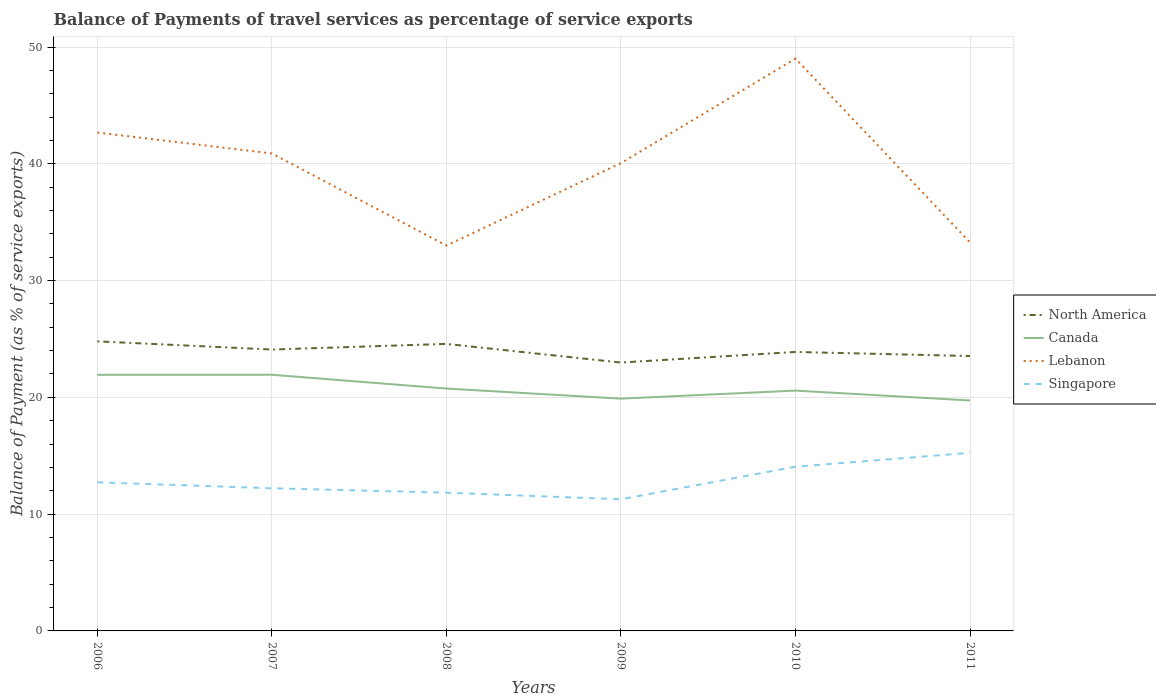Does the line corresponding to North America intersect with the line corresponding to Lebanon?
Your response must be concise. No. Across all years, what is the maximum balance of payments of travel services in Singapore?
Your answer should be very brief. 11.27. In which year was the balance of payments of travel services in Canada maximum?
Your response must be concise. 2011. What is the total balance of payments of travel services in Singapore in the graph?
Offer a very short reply. 0.51. What is the difference between the highest and the second highest balance of payments of travel services in Lebanon?
Make the answer very short. 16.01. Does the graph contain any zero values?
Your response must be concise. No. Does the graph contain grids?
Keep it short and to the point. Yes. How are the legend labels stacked?
Your response must be concise. Vertical. What is the title of the graph?
Offer a terse response. Balance of Payments of travel services as percentage of service exports. Does "Congo (Democratic)" appear as one of the legend labels in the graph?
Your answer should be very brief. No. What is the label or title of the X-axis?
Give a very brief answer. Years. What is the label or title of the Y-axis?
Your answer should be compact. Balance of Payment (as % of service exports). What is the Balance of Payment (as % of service exports) in North America in 2006?
Offer a terse response. 24.8. What is the Balance of Payment (as % of service exports) of Canada in 2006?
Provide a short and direct response. 21.93. What is the Balance of Payment (as % of service exports) of Lebanon in 2006?
Your answer should be very brief. 42.68. What is the Balance of Payment (as % of service exports) in Singapore in 2006?
Offer a terse response. 12.73. What is the Balance of Payment (as % of service exports) in North America in 2007?
Offer a terse response. 24.1. What is the Balance of Payment (as % of service exports) in Canada in 2007?
Provide a succinct answer. 21.94. What is the Balance of Payment (as % of service exports) in Lebanon in 2007?
Give a very brief answer. 40.89. What is the Balance of Payment (as % of service exports) of Singapore in 2007?
Ensure brevity in your answer.  12.22. What is the Balance of Payment (as % of service exports) of North America in 2008?
Give a very brief answer. 24.58. What is the Balance of Payment (as % of service exports) in Canada in 2008?
Your response must be concise. 20.75. What is the Balance of Payment (as % of service exports) in Lebanon in 2008?
Offer a very short reply. 33. What is the Balance of Payment (as % of service exports) of Singapore in 2008?
Offer a terse response. 11.84. What is the Balance of Payment (as % of service exports) in North America in 2009?
Provide a short and direct response. 22.98. What is the Balance of Payment (as % of service exports) in Canada in 2009?
Your answer should be very brief. 19.89. What is the Balance of Payment (as % of service exports) in Lebanon in 2009?
Keep it short and to the point. 40.06. What is the Balance of Payment (as % of service exports) of Singapore in 2009?
Your response must be concise. 11.27. What is the Balance of Payment (as % of service exports) of North America in 2010?
Provide a short and direct response. 23.89. What is the Balance of Payment (as % of service exports) in Canada in 2010?
Provide a short and direct response. 20.58. What is the Balance of Payment (as % of service exports) in Lebanon in 2010?
Offer a terse response. 49.01. What is the Balance of Payment (as % of service exports) of Singapore in 2010?
Your answer should be compact. 14.06. What is the Balance of Payment (as % of service exports) of North America in 2011?
Ensure brevity in your answer.  23.54. What is the Balance of Payment (as % of service exports) in Canada in 2011?
Your answer should be very brief. 19.73. What is the Balance of Payment (as % of service exports) of Lebanon in 2011?
Your response must be concise. 33.27. What is the Balance of Payment (as % of service exports) in Singapore in 2011?
Keep it short and to the point. 15.25. Across all years, what is the maximum Balance of Payment (as % of service exports) in North America?
Provide a succinct answer. 24.8. Across all years, what is the maximum Balance of Payment (as % of service exports) of Canada?
Your answer should be very brief. 21.94. Across all years, what is the maximum Balance of Payment (as % of service exports) in Lebanon?
Keep it short and to the point. 49.01. Across all years, what is the maximum Balance of Payment (as % of service exports) of Singapore?
Provide a succinct answer. 15.25. Across all years, what is the minimum Balance of Payment (as % of service exports) of North America?
Your response must be concise. 22.98. Across all years, what is the minimum Balance of Payment (as % of service exports) in Canada?
Offer a terse response. 19.73. Across all years, what is the minimum Balance of Payment (as % of service exports) of Lebanon?
Give a very brief answer. 33. Across all years, what is the minimum Balance of Payment (as % of service exports) in Singapore?
Offer a terse response. 11.27. What is the total Balance of Payment (as % of service exports) in North America in the graph?
Provide a short and direct response. 143.88. What is the total Balance of Payment (as % of service exports) of Canada in the graph?
Your answer should be very brief. 124.82. What is the total Balance of Payment (as % of service exports) in Lebanon in the graph?
Make the answer very short. 238.89. What is the total Balance of Payment (as % of service exports) in Singapore in the graph?
Provide a succinct answer. 77.36. What is the difference between the Balance of Payment (as % of service exports) in North America in 2006 and that in 2007?
Make the answer very short. 0.7. What is the difference between the Balance of Payment (as % of service exports) in Canada in 2006 and that in 2007?
Your answer should be compact. -0.01. What is the difference between the Balance of Payment (as % of service exports) in Lebanon in 2006 and that in 2007?
Offer a very short reply. 1.79. What is the difference between the Balance of Payment (as % of service exports) in Singapore in 2006 and that in 2007?
Your response must be concise. 0.51. What is the difference between the Balance of Payment (as % of service exports) in North America in 2006 and that in 2008?
Keep it short and to the point. 0.22. What is the difference between the Balance of Payment (as % of service exports) in Canada in 2006 and that in 2008?
Offer a very short reply. 1.18. What is the difference between the Balance of Payment (as % of service exports) in Lebanon in 2006 and that in 2008?
Offer a very short reply. 9.68. What is the difference between the Balance of Payment (as % of service exports) in North America in 2006 and that in 2009?
Provide a succinct answer. 1.82. What is the difference between the Balance of Payment (as % of service exports) in Canada in 2006 and that in 2009?
Keep it short and to the point. 2.04. What is the difference between the Balance of Payment (as % of service exports) in Lebanon in 2006 and that in 2009?
Your response must be concise. 2.62. What is the difference between the Balance of Payment (as % of service exports) of Singapore in 2006 and that in 2009?
Your answer should be very brief. 1.45. What is the difference between the Balance of Payment (as % of service exports) of North America in 2006 and that in 2010?
Keep it short and to the point. 0.91. What is the difference between the Balance of Payment (as % of service exports) of Canada in 2006 and that in 2010?
Make the answer very short. 1.35. What is the difference between the Balance of Payment (as % of service exports) in Lebanon in 2006 and that in 2010?
Your response must be concise. -6.33. What is the difference between the Balance of Payment (as % of service exports) of Singapore in 2006 and that in 2010?
Give a very brief answer. -1.33. What is the difference between the Balance of Payment (as % of service exports) in North America in 2006 and that in 2011?
Provide a short and direct response. 1.26. What is the difference between the Balance of Payment (as % of service exports) in Canada in 2006 and that in 2011?
Keep it short and to the point. 2.2. What is the difference between the Balance of Payment (as % of service exports) of Lebanon in 2006 and that in 2011?
Give a very brief answer. 9.41. What is the difference between the Balance of Payment (as % of service exports) of Singapore in 2006 and that in 2011?
Offer a very short reply. -2.53. What is the difference between the Balance of Payment (as % of service exports) of North America in 2007 and that in 2008?
Offer a very short reply. -0.48. What is the difference between the Balance of Payment (as % of service exports) of Canada in 2007 and that in 2008?
Keep it short and to the point. 1.18. What is the difference between the Balance of Payment (as % of service exports) in Lebanon in 2007 and that in 2008?
Offer a terse response. 7.89. What is the difference between the Balance of Payment (as % of service exports) of Singapore in 2007 and that in 2008?
Ensure brevity in your answer.  0.38. What is the difference between the Balance of Payment (as % of service exports) of North America in 2007 and that in 2009?
Offer a terse response. 1.11. What is the difference between the Balance of Payment (as % of service exports) of Canada in 2007 and that in 2009?
Your answer should be compact. 2.04. What is the difference between the Balance of Payment (as % of service exports) of Lebanon in 2007 and that in 2009?
Keep it short and to the point. 0.83. What is the difference between the Balance of Payment (as % of service exports) in Singapore in 2007 and that in 2009?
Your answer should be compact. 0.94. What is the difference between the Balance of Payment (as % of service exports) of North America in 2007 and that in 2010?
Make the answer very short. 0.21. What is the difference between the Balance of Payment (as % of service exports) in Canada in 2007 and that in 2010?
Offer a terse response. 1.36. What is the difference between the Balance of Payment (as % of service exports) in Lebanon in 2007 and that in 2010?
Offer a terse response. -8.12. What is the difference between the Balance of Payment (as % of service exports) in Singapore in 2007 and that in 2010?
Your answer should be compact. -1.84. What is the difference between the Balance of Payment (as % of service exports) of North America in 2007 and that in 2011?
Offer a terse response. 0.56. What is the difference between the Balance of Payment (as % of service exports) in Canada in 2007 and that in 2011?
Give a very brief answer. 2.2. What is the difference between the Balance of Payment (as % of service exports) of Lebanon in 2007 and that in 2011?
Keep it short and to the point. 7.62. What is the difference between the Balance of Payment (as % of service exports) in Singapore in 2007 and that in 2011?
Make the answer very short. -3.04. What is the difference between the Balance of Payment (as % of service exports) of North America in 2008 and that in 2009?
Ensure brevity in your answer.  1.6. What is the difference between the Balance of Payment (as % of service exports) in Canada in 2008 and that in 2009?
Keep it short and to the point. 0.86. What is the difference between the Balance of Payment (as % of service exports) in Lebanon in 2008 and that in 2009?
Make the answer very short. -7.06. What is the difference between the Balance of Payment (as % of service exports) in Singapore in 2008 and that in 2009?
Your answer should be compact. 0.56. What is the difference between the Balance of Payment (as % of service exports) of North America in 2008 and that in 2010?
Provide a succinct answer. 0.69. What is the difference between the Balance of Payment (as % of service exports) in Canada in 2008 and that in 2010?
Ensure brevity in your answer.  0.18. What is the difference between the Balance of Payment (as % of service exports) in Lebanon in 2008 and that in 2010?
Give a very brief answer. -16.01. What is the difference between the Balance of Payment (as % of service exports) in Singapore in 2008 and that in 2010?
Make the answer very short. -2.22. What is the difference between the Balance of Payment (as % of service exports) of North America in 2008 and that in 2011?
Offer a very short reply. 1.04. What is the difference between the Balance of Payment (as % of service exports) in Canada in 2008 and that in 2011?
Ensure brevity in your answer.  1.02. What is the difference between the Balance of Payment (as % of service exports) of Lebanon in 2008 and that in 2011?
Make the answer very short. -0.27. What is the difference between the Balance of Payment (as % of service exports) in Singapore in 2008 and that in 2011?
Your answer should be compact. -3.42. What is the difference between the Balance of Payment (as % of service exports) in North America in 2009 and that in 2010?
Your response must be concise. -0.91. What is the difference between the Balance of Payment (as % of service exports) of Canada in 2009 and that in 2010?
Provide a succinct answer. -0.69. What is the difference between the Balance of Payment (as % of service exports) in Lebanon in 2009 and that in 2010?
Your response must be concise. -8.95. What is the difference between the Balance of Payment (as % of service exports) in Singapore in 2009 and that in 2010?
Give a very brief answer. -2.79. What is the difference between the Balance of Payment (as % of service exports) of North America in 2009 and that in 2011?
Offer a terse response. -0.56. What is the difference between the Balance of Payment (as % of service exports) in Canada in 2009 and that in 2011?
Offer a very short reply. 0.16. What is the difference between the Balance of Payment (as % of service exports) in Lebanon in 2009 and that in 2011?
Make the answer very short. 6.79. What is the difference between the Balance of Payment (as % of service exports) in Singapore in 2009 and that in 2011?
Keep it short and to the point. -3.98. What is the difference between the Balance of Payment (as % of service exports) of North America in 2010 and that in 2011?
Make the answer very short. 0.35. What is the difference between the Balance of Payment (as % of service exports) in Canada in 2010 and that in 2011?
Keep it short and to the point. 0.84. What is the difference between the Balance of Payment (as % of service exports) in Lebanon in 2010 and that in 2011?
Your answer should be compact. 15.74. What is the difference between the Balance of Payment (as % of service exports) in Singapore in 2010 and that in 2011?
Provide a succinct answer. -1.19. What is the difference between the Balance of Payment (as % of service exports) in North America in 2006 and the Balance of Payment (as % of service exports) in Canada in 2007?
Your answer should be compact. 2.86. What is the difference between the Balance of Payment (as % of service exports) in North America in 2006 and the Balance of Payment (as % of service exports) in Lebanon in 2007?
Give a very brief answer. -16.09. What is the difference between the Balance of Payment (as % of service exports) in North America in 2006 and the Balance of Payment (as % of service exports) in Singapore in 2007?
Keep it short and to the point. 12.58. What is the difference between the Balance of Payment (as % of service exports) in Canada in 2006 and the Balance of Payment (as % of service exports) in Lebanon in 2007?
Your answer should be very brief. -18.96. What is the difference between the Balance of Payment (as % of service exports) in Canada in 2006 and the Balance of Payment (as % of service exports) in Singapore in 2007?
Provide a succinct answer. 9.71. What is the difference between the Balance of Payment (as % of service exports) in Lebanon in 2006 and the Balance of Payment (as % of service exports) in Singapore in 2007?
Provide a succinct answer. 30.46. What is the difference between the Balance of Payment (as % of service exports) in North America in 2006 and the Balance of Payment (as % of service exports) in Canada in 2008?
Give a very brief answer. 4.04. What is the difference between the Balance of Payment (as % of service exports) of North America in 2006 and the Balance of Payment (as % of service exports) of Lebanon in 2008?
Keep it short and to the point. -8.2. What is the difference between the Balance of Payment (as % of service exports) in North America in 2006 and the Balance of Payment (as % of service exports) in Singapore in 2008?
Provide a short and direct response. 12.96. What is the difference between the Balance of Payment (as % of service exports) of Canada in 2006 and the Balance of Payment (as % of service exports) of Lebanon in 2008?
Provide a succinct answer. -11.07. What is the difference between the Balance of Payment (as % of service exports) of Canada in 2006 and the Balance of Payment (as % of service exports) of Singapore in 2008?
Give a very brief answer. 10.09. What is the difference between the Balance of Payment (as % of service exports) of Lebanon in 2006 and the Balance of Payment (as % of service exports) of Singapore in 2008?
Your answer should be compact. 30.84. What is the difference between the Balance of Payment (as % of service exports) in North America in 2006 and the Balance of Payment (as % of service exports) in Canada in 2009?
Your answer should be very brief. 4.9. What is the difference between the Balance of Payment (as % of service exports) in North America in 2006 and the Balance of Payment (as % of service exports) in Lebanon in 2009?
Make the answer very short. -15.26. What is the difference between the Balance of Payment (as % of service exports) in North America in 2006 and the Balance of Payment (as % of service exports) in Singapore in 2009?
Offer a very short reply. 13.52. What is the difference between the Balance of Payment (as % of service exports) in Canada in 2006 and the Balance of Payment (as % of service exports) in Lebanon in 2009?
Ensure brevity in your answer.  -18.13. What is the difference between the Balance of Payment (as % of service exports) in Canada in 2006 and the Balance of Payment (as % of service exports) in Singapore in 2009?
Provide a succinct answer. 10.66. What is the difference between the Balance of Payment (as % of service exports) in Lebanon in 2006 and the Balance of Payment (as % of service exports) in Singapore in 2009?
Offer a terse response. 31.4. What is the difference between the Balance of Payment (as % of service exports) of North America in 2006 and the Balance of Payment (as % of service exports) of Canada in 2010?
Offer a very short reply. 4.22. What is the difference between the Balance of Payment (as % of service exports) of North America in 2006 and the Balance of Payment (as % of service exports) of Lebanon in 2010?
Ensure brevity in your answer.  -24.21. What is the difference between the Balance of Payment (as % of service exports) of North America in 2006 and the Balance of Payment (as % of service exports) of Singapore in 2010?
Provide a short and direct response. 10.74. What is the difference between the Balance of Payment (as % of service exports) of Canada in 2006 and the Balance of Payment (as % of service exports) of Lebanon in 2010?
Your response must be concise. -27.08. What is the difference between the Balance of Payment (as % of service exports) in Canada in 2006 and the Balance of Payment (as % of service exports) in Singapore in 2010?
Your answer should be compact. 7.87. What is the difference between the Balance of Payment (as % of service exports) of Lebanon in 2006 and the Balance of Payment (as % of service exports) of Singapore in 2010?
Give a very brief answer. 28.61. What is the difference between the Balance of Payment (as % of service exports) of North America in 2006 and the Balance of Payment (as % of service exports) of Canada in 2011?
Make the answer very short. 5.06. What is the difference between the Balance of Payment (as % of service exports) in North America in 2006 and the Balance of Payment (as % of service exports) in Lebanon in 2011?
Offer a very short reply. -8.47. What is the difference between the Balance of Payment (as % of service exports) in North America in 2006 and the Balance of Payment (as % of service exports) in Singapore in 2011?
Give a very brief answer. 9.54. What is the difference between the Balance of Payment (as % of service exports) of Canada in 2006 and the Balance of Payment (as % of service exports) of Lebanon in 2011?
Your answer should be very brief. -11.34. What is the difference between the Balance of Payment (as % of service exports) of Canada in 2006 and the Balance of Payment (as % of service exports) of Singapore in 2011?
Provide a succinct answer. 6.68. What is the difference between the Balance of Payment (as % of service exports) in Lebanon in 2006 and the Balance of Payment (as % of service exports) in Singapore in 2011?
Your response must be concise. 27.42. What is the difference between the Balance of Payment (as % of service exports) of North America in 2007 and the Balance of Payment (as % of service exports) of Canada in 2008?
Provide a succinct answer. 3.34. What is the difference between the Balance of Payment (as % of service exports) of North America in 2007 and the Balance of Payment (as % of service exports) of Lebanon in 2008?
Offer a very short reply. -8.9. What is the difference between the Balance of Payment (as % of service exports) of North America in 2007 and the Balance of Payment (as % of service exports) of Singapore in 2008?
Your response must be concise. 12.26. What is the difference between the Balance of Payment (as % of service exports) in Canada in 2007 and the Balance of Payment (as % of service exports) in Lebanon in 2008?
Make the answer very short. -11.06. What is the difference between the Balance of Payment (as % of service exports) in Canada in 2007 and the Balance of Payment (as % of service exports) in Singapore in 2008?
Offer a terse response. 10.1. What is the difference between the Balance of Payment (as % of service exports) of Lebanon in 2007 and the Balance of Payment (as % of service exports) of Singapore in 2008?
Provide a succinct answer. 29.05. What is the difference between the Balance of Payment (as % of service exports) of North America in 2007 and the Balance of Payment (as % of service exports) of Canada in 2009?
Provide a succinct answer. 4.2. What is the difference between the Balance of Payment (as % of service exports) in North America in 2007 and the Balance of Payment (as % of service exports) in Lebanon in 2009?
Provide a short and direct response. -15.96. What is the difference between the Balance of Payment (as % of service exports) of North America in 2007 and the Balance of Payment (as % of service exports) of Singapore in 2009?
Keep it short and to the point. 12.82. What is the difference between the Balance of Payment (as % of service exports) in Canada in 2007 and the Balance of Payment (as % of service exports) in Lebanon in 2009?
Ensure brevity in your answer.  -18.12. What is the difference between the Balance of Payment (as % of service exports) of Canada in 2007 and the Balance of Payment (as % of service exports) of Singapore in 2009?
Your answer should be compact. 10.66. What is the difference between the Balance of Payment (as % of service exports) in Lebanon in 2007 and the Balance of Payment (as % of service exports) in Singapore in 2009?
Keep it short and to the point. 29.61. What is the difference between the Balance of Payment (as % of service exports) in North America in 2007 and the Balance of Payment (as % of service exports) in Canada in 2010?
Offer a very short reply. 3.52. What is the difference between the Balance of Payment (as % of service exports) in North America in 2007 and the Balance of Payment (as % of service exports) in Lebanon in 2010?
Provide a short and direct response. -24.91. What is the difference between the Balance of Payment (as % of service exports) in North America in 2007 and the Balance of Payment (as % of service exports) in Singapore in 2010?
Provide a succinct answer. 10.04. What is the difference between the Balance of Payment (as % of service exports) of Canada in 2007 and the Balance of Payment (as % of service exports) of Lebanon in 2010?
Provide a succinct answer. -27.07. What is the difference between the Balance of Payment (as % of service exports) in Canada in 2007 and the Balance of Payment (as % of service exports) in Singapore in 2010?
Provide a short and direct response. 7.87. What is the difference between the Balance of Payment (as % of service exports) of Lebanon in 2007 and the Balance of Payment (as % of service exports) of Singapore in 2010?
Provide a short and direct response. 26.82. What is the difference between the Balance of Payment (as % of service exports) in North America in 2007 and the Balance of Payment (as % of service exports) in Canada in 2011?
Keep it short and to the point. 4.36. What is the difference between the Balance of Payment (as % of service exports) in North America in 2007 and the Balance of Payment (as % of service exports) in Lebanon in 2011?
Offer a terse response. -9.17. What is the difference between the Balance of Payment (as % of service exports) in North America in 2007 and the Balance of Payment (as % of service exports) in Singapore in 2011?
Provide a short and direct response. 8.84. What is the difference between the Balance of Payment (as % of service exports) in Canada in 2007 and the Balance of Payment (as % of service exports) in Lebanon in 2011?
Provide a succinct answer. -11.33. What is the difference between the Balance of Payment (as % of service exports) of Canada in 2007 and the Balance of Payment (as % of service exports) of Singapore in 2011?
Your answer should be very brief. 6.68. What is the difference between the Balance of Payment (as % of service exports) of Lebanon in 2007 and the Balance of Payment (as % of service exports) of Singapore in 2011?
Offer a very short reply. 25.63. What is the difference between the Balance of Payment (as % of service exports) in North America in 2008 and the Balance of Payment (as % of service exports) in Canada in 2009?
Your answer should be very brief. 4.68. What is the difference between the Balance of Payment (as % of service exports) of North America in 2008 and the Balance of Payment (as % of service exports) of Lebanon in 2009?
Make the answer very short. -15.48. What is the difference between the Balance of Payment (as % of service exports) of North America in 2008 and the Balance of Payment (as % of service exports) of Singapore in 2009?
Your response must be concise. 13.3. What is the difference between the Balance of Payment (as % of service exports) in Canada in 2008 and the Balance of Payment (as % of service exports) in Lebanon in 2009?
Your response must be concise. -19.31. What is the difference between the Balance of Payment (as % of service exports) of Canada in 2008 and the Balance of Payment (as % of service exports) of Singapore in 2009?
Make the answer very short. 9.48. What is the difference between the Balance of Payment (as % of service exports) of Lebanon in 2008 and the Balance of Payment (as % of service exports) of Singapore in 2009?
Make the answer very short. 21.72. What is the difference between the Balance of Payment (as % of service exports) in North America in 2008 and the Balance of Payment (as % of service exports) in Canada in 2010?
Provide a succinct answer. 4. What is the difference between the Balance of Payment (as % of service exports) in North America in 2008 and the Balance of Payment (as % of service exports) in Lebanon in 2010?
Make the answer very short. -24.43. What is the difference between the Balance of Payment (as % of service exports) in North America in 2008 and the Balance of Payment (as % of service exports) in Singapore in 2010?
Give a very brief answer. 10.52. What is the difference between the Balance of Payment (as % of service exports) in Canada in 2008 and the Balance of Payment (as % of service exports) in Lebanon in 2010?
Give a very brief answer. -28.25. What is the difference between the Balance of Payment (as % of service exports) in Canada in 2008 and the Balance of Payment (as % of service exports) in Singapore in 2010?
Provide a succinct answer. 6.69. What is the difference between the Balance of Payment (as % of service exports) of Lebanon in 2008 and the Balance of Payment (as % of service exports) of Singapore in 2010?
Provide a succinct answer. 18.94. What is the difference between the Balance of Payment (as % of service exports) of North America in 2008 and the Balance of Payment (as % of service exports) of Canada in 2011?
Offer a very short reply. 4.84. What is the difference between the Balance of Payment (as % of service exports) in North America in 2008 and the Balance of Payment (as % of service exports) in Lebanon in 2011?
Ensure brevity in your answer.  -8.69. What is the difference between the Balance of Payment (as % of service exports) in North America in 2008 and the Balance of Payment (as % of service exports) in Singapore in 2011?
Your answer should be compact. 9.32. What is the difference between the Balance of Payment (as % of service exports) of Canada in 2008 and the Balance of Payment (as % of service exports) of Lebanon in 2011?
Provide a succinct answer. -12.51. What is the difference between the Balance of Payment (as % of service exports) in Canada in 2008 and the Balance of Payment (as % of service exports) in Singapore in 2011?
Your answer should be very brief. 5.5. What is the difference between the Balance of Payment (as % of service exports) in Lebanon in 2008 and the Balance of Payment (as % of service exports) in Singapore in 2011?
Your answer should be compact. 17.74. What is the difference between the Balance of Payment (as % of service exports) in North America in 2009 and the Balance of Payment (as % of service exports) in Canada in 2010?
Provide a short and direct response. 2.4. What is the difference between the Balance of Payment (as % of service exports) in North America in 2009 and the Balance of Payment (as % of service exports) in Lebanon in 2010?
Your answer should be very brief. -26.03. What is the difference between the Balance of Payment (as % of service exports) in North America in 2009 and the Balance of Payment (as % of service exports) in Singapore in 2010?
Your answer should be compact. 8.92. What is the difference between the Balance of Payment (as % of service exports) of Canada in 2009 and the Balance of Payment (as % of service exports) of Lebanon in 2010?
Keep it short and to the point. -29.11. What is the difference between the Balance of Payment (as % of service exports) of Canada in 2009 and the Balance of Payment (as % of service exports) of Singapore in 2010?
Provide a short and direct response. 5.83. What is the difference between the Balance of Payment (as % of service exports) of Lebanon in 2009 and the Balance of Payment (as % of service exports) of Singapore in 2010?
Make the answer very short. 26. What is the difference between the Balance of Payment (as % of service exports) in North America in 2009 and the Balance of Payment (as % of service exports) in Canada in 2011?
Provide a succinct answer. 3.25. What is the difference between the Balance of Payment (as % of service exports) in North America in 2009 and the Balance of Payment (as % of service exports) in Lebanon in 2011?
Your answer should be compact. -10.29. What is the difference between the Balance of Payment (as % of service exports) in North America in 2009 and the Balance of Payment (as % of service exports) in Singapore in 2011?
Your answer should be compact. 7.73. What is the difference between the Balance of Payment (as % of service exports) of Canada in 2009 and the Balance of Payment (as % of service exports) of Lebanon in 2011?
Make the answer very short. -13.38. What is the difference between the Balance of Payment (as % of service exports) in Canada in 2009 and the Balance of Payment (as % of service exports) in Singapore in 2011?
Your response must be concise. 4.64. What is the difference between the Balance of Payment (as % of service exports) of Lebanon in 2009 and the Balance of Payment (as % of service exports) of Singapore in 2011?
Your answer should be very brief. 24.81. What is the difference between the Balance of Payment (as % of service exports) in North America in 2010 and the Balance of Payment (as % of service exports) in Canada in 2011?
Offer a terse response. 4.16. What is the difference between the Balance of Payment (as % of service exports) of North America in 2010 and the Balance of Payment (as % of service exports) of Lebanon in 2011?
Make the answer very short. -9.38. What is the difference between the Balance of Payment (as % of service exports) in North America in 2010 and the Balance of Payment (as % of service exports) in Singapore in 2011?
Offer a terse response. 8.64. What is the difference between the Balance of Payment (as % of service exports) of Canada in 2010 and the Balance of Payment (as % of service exports) of Lebanon in 2011?
Your response must be concise. -12.69. What is the difference between the Balance of Payment (as % of service exports) of Canada in 2010 and the Balance of Payment (as % of service exports) of Singapore in 2011?
Keep it short and to the point. 5.33. What is the difference between the Balance of Payment (as % of service exports) in Lebanon in 2010 and the Balance of Payment (as % of service exports) in Singapore in 2011?
Make the answer very short. 33.75. What is the average Balance of Payment (as % of service exports) in North America per year?
Keep it short and to the point. 23.98. What is the average Balance of Payment (as % of service exports) of Canada per year?
Your response must be concise. 20.8. What is the average Balance of Payment (as % of service exports) of Lebanon per year?
Offer a very short reply. 39.82. What is the average Balance of Payment (as % of service exports) in Singapore per year?
Ensure brevity in your answer.  12.89. In the year 2006, what is the difference between the Balance of Payment (as % of service exports) of North America and Balance of Payment (as % of service exports) of Canada?
Make the answer very short. 2.87. In the year 2006, what is the difference between the Balance of Payment (as % of service exports) of North America and Balance of Payment (as % of service exports) of Lebanon?
Your response must be concise. -17.88. In the year 2006, what is the difference between the Balance of Payment (as % of service exports) in North America and Balance of Payment (as % of service exports) in Singapore?
Your answer should be very brief. 12.07. In the year 2006, what is the difference between the Balance of Payment (as % of service exports) in Canada and Balance of Payment (as % of service exports) in Lebanon?
Provide a succinct answer. -20.75. In the year 2006, what is the difference between the Balance of Payment (as % of service exports) of Canada and Balance of Payment (as % of service exports) of Singapore?
Keep it short and to the point. 9.2. In the year 2006, what is the difference between the Balance of Payment (as % of service exports) of Lebanon and Balance of Payment (as % of service exports) of Singapore?
Your answer should be compact. 29.95. In the year 2007, what is the difference between the Balance of Payment (as % of service exports) in North America and Balance of Payment (as % of service exports) in Canada?
Your answer should be very brief. 2.16. In the year 2007, what is the difference between the Balance of Payment (as % of service exports) of North America and Balance of Payment (as % of service exports) of Lebanon?
Your answer should be very brief. -16.79. In the year 2007, what is the difference between the Balance of Payment (as % of service exports) of North America and Balance of Payment (as % of service exports) of Singapore?
Offer a very short reply. 11.88. In the year 2007, what is the difference between the Balance of Payment (as % of service exports) of Canada and Balance of Payment (as % of service exports) of Lebanon?
Your response must be concise. -18.95. In the year 2007, what is the difference between the Balance of Payment (as % of service exports) in Canada and Balance of Payment (as % of service exports) in Singapore?
Keep it short and to the point. 9.72. In the year 2007, what is the difference between the Balance of Payment (as % of service exports) of Lebanon and Balance of Payment (as % of service exports) of Singapore?
Keep it short and to the point. 28.67. In the year 2008, what is the difference between the Balance of Payment (as % of service exports) in North America and Balance of Payment (as % of service exports) in Canada?
Ensure brevity in your answer.  3.82. In the year 2008, what is the difference between the Balance of Payment (as % of service exports) in North America and Balance of Payment (as % of service exports) in Lebanon?
Ensure brevity in your answer.  -8.42. In the year 2008, what is the difference between the Balance of Payment (as % of service exports) in North America and Balance of Payment (as % of service exports) in Singapore?
Give a very brief answer. 12.74. In the year 2008, what is the difference between the Balance of Payment (as % of service exports) in Canada and Balance of Payment (as % of service exports) in Lebanon?
Ensure brevity in your answer.  -12.24. In the year 2008, what is the difference between the Balance of Payment (as % of service exports) in Canada and Balance of Payment (as % of service exports) in Singapore?
Your answer should be very brief. 8.92. In the year 2008, what is the difference between the Balance of Payment (as % of service exports) in Lebanon and Balance of Payment (as % of service exports) in Singapore?
Provide a short and direct response. 21.16. In the year 2009, what is the difference between the Balance of Payment (as % of service exports) in North America and Balance of Payment (as % of service exports) in Canada?
Offer a very short reply. 3.09. In the year 2009, what is the difference between the Balance of Payment (as % of service exports) of North America and Balance of Payment (as % of service exports) of Lebanon?
Provide a short and direct response. -17.08. In the year 2009, what is the difference between the Balance of Payment (as % of service exports) in North America and Balance of Payment (as % of service exports) in Singapore?
Your response must be concise. 11.71. In the year 2009, what is the difference between the Balance of Payment (as % of service exports) of Canada and Balance of Payment (as % of service exports) of Lebanon?
Make the answer very short. -20.17. In the year 2009, what is the difference between the Balance of Payment (as % of service exports) in Canada and Balance of Payment (as % of service exports) in Singapore?
Keep it short and to the point. 8.62. In the year 2009, what is the difference between the Balance of Payment (as % of service exports) in Lebanon and Balance of Payment (as % of service exports) in Singapore?
Your response must be concise. 28.79. In the year 2010, what is the difference between the Balance of Payment (as % of service exports) of North America and Balance of Payment (as % of service exports) of Canada?
Provide a succinct answer. 3.31. In the year 2010, what is the difference between the Balance of Payment (as % of service exports) in North America and Balance of Payment (as % of service exports) in Lebanon?
Provide a succinct answer. -25.12. In the year 2010, what is the difference between the Balance of Payment (as % of service exports) in North America and Balance of Payment (as % of service exports) in Singapore?
Keep it short and to the point. 9.83. In the year 2010, what is the difference between the Balance of Payment (as % of service exports) in Canada and Balance of Payment (as % of service exports) in Lebanon?
Keep it short and to the point. -28.43. In the year 2010, what is the difference between the Balance of Payment (as % of service exports) of Canada and Balance of Payment (as % of service exports) of Singapore?
Keep it short and to the point. 6.52. In the year 2010, what is the difference between the Balance of Payment (as % of service exports) of Lebanon and Balance of Payment (as % of service exports) of Singapore?
Provide a succinct answer. 34.95. In the year 2011, what is the difference between the Balance of Payment (as % of service exports) of North America and Balance of Payment (as % of service exports) of Canada?
Provide a succinct answer. 3.81. In the year 2011, what is the difference between the Balance of Payment (as % of service exports) of North America and Balance of Payment (as % of service exports) of Lebanon?
Give a very brief answer. -9.73. In the year 2011, what is the difference between the Balance of Payment (as % of service exports) in North America and Balance of Payment (as % of service exports) in Singapore?
Give a very brief answer. 8.29. In the year 2011, what is the difference between the Balance of Payment (as % of service exports) of Canada and Balance of Payment (as % of service exports) of Lebanon?
Provide a succinct answer. -13.54. In the year 2011, what is the difference between the Balance of Payment (as % of service exports) of Canada and Balance of Payment (as % of service exports) of Singapore?
Your answer should be compact. 4.48. In the year 2011, what is the difference between the Balance of Payment (as % of service exports) in Lebanon and Balance of Payment (as % of service exports) in Singapore?
Offer a very short reply. 18.02. What is the ratio of the Balance of Payment (as % of service exports) in North America in 2006 to that in 2007?
Offer a terse response. 1.03. What is the ratio of the Balance of Payment (as % of service exports) in Lebanon in 2006 to that in 2007?
Provide a succinct answer. 1.04. What is the ratio of the Balance of Payment (as % of service exports) in Singapore in 2006 to that in 2007?
Offer a terse response. 1.04. What is the ratio of the Balance of Payment (as % of service exports) of North America in 2006 to that in 2008?
Make the answer very short. 1.01. What is the ratio of the Balance of Payment (as % of service exports) in Canada in 2006 to that in 2008?
Offer a terse response. 1.06. What is the ratio of the Balance of Payment (as % of service exports) in Lebanon in 2006 to that in 2008?
Your answer should be very brief. 1.29. What is the ratio of the Balance of Payment (as % of service exports) in Singapore in 2006 to that in 2008?
Offer a terse response. 1.08. What is the ratio of the Balance of Payment (as % of service exports) of North America in 2006 to that in 2009?
Your response must be concise. 1.08. What is the ratio of the Balance of Payment (as % of service exports) of Canada in 2006 to that in 2009?
Your answer should be very brief. 1.1. What is the ratio of the Balance of Payment (as % of service exports) of Lebanon in 2006 to that in 2009?
Provide a short and direct response. 1.07. What is the ratio of the Balance of Payment (as % of service exports) in Singapore in 2006 to that in 2009?
Provide a succinct answer. 1.13. What is the ratio of the Balance of Payment (as % of service exports) in North America in 2006 to that in 2010?
Your response must be concise. 1.04. What is the ratio of the Balance of Payment (as % of service exports) of Canada in 2006 to that in 2010?
Your response must be concise. 1.07. What is the ratio of the Balance of Payment (as % of service exports) of Lebanon in 2006 to that in 2010?
Your answer should be very brief. 0.87. What is the ratio of the Balance of Payment (as % of service exports) of Singapore in 2006 to that in 2010?
Offer a very short reply. 0.91. What is the ratio of the Balance of Payment (as % of service exports) in North America in 2006 to that in 2011?
Make the answer very short. 1.05. What is the ratio of the Balance of Payment (as % of service exports) in Canada in 2006 to that in 2011?
Give a very brief answer. 1.11. What is the ratio of the Balance of Payment (as % of service exports) in Lebanon in 2006 to that in 2011?
Provide a short and direct response. 1.28. What is the ratio of the Balance of Payment (as % of service exports) in Singapore in 2006 to that in 2011?
Give a very brief answer. 0.83. What is the ratio of the Balance of Payment (as % of service exports) of North America in 2007 to that in 2008?
Offer a terse response. 0.98. What is the ratio of the Balance of Payment (as % of service exports) in Canada in 2007 to that in 2008?
Offer a terse response. 1.06. What is the ratio of the Balance of Payment (as % of service exports) of Lebanon in 2007 to that in 2008?
Provide a succinct answer. 1.24. What is the ratio of the Balance of Payment (as % of service exports) of Singapore in 2007 to that in 2008?
Your answer should be very brief. 1.03. What is the ratio of the Balance of Payment (as % of service exports) of North America in 2007 to that in 2009?
Offer a terse response. 1.05. What is the ratio of the Balance of Payment (as % of service exports) in Canada in 2007 to that in 2009?
Ensure brevity in your answer.  1.1. What is the ratio of the Balance of Payment (as % of service exports) of Lebanon in 2007 to that in 2009?
Your answer should be compact. 1.02. What is the ratio of the Balance of Payment (as % of service exports) of Singapore in 2007 to that in 2009?
Your answer should be very brief. 1.08. What is the ratio of the Balance of Payment (as % of service exports) of North America in 2007 to that in 2010?
Give a very brief answer. 1.01. What is the ratio of the Balance of Payment (as % of service exports) of Canada in 2007 to that in 2010?
Give a very brief answer. 1.07. What is the ratio of the Balance of Payment (as % of service exports) in Lebanon in 2007 to that in 2010?
Provide a succinct answer. 0.83. What is the ratio of the Balance of Payment (as % of service exports) of Singapore in 2007 to that in 2010?
Your answer should be very brief. 0.87. What is the ratio of the Balance of Payment (as % of service exports) of North America in 2007 to that in 2011?
Make the answer very short. 1.02. What is the ratio of the Balance of Payment (as % of service exports) in Canada in 2007 to that in 2011?
Keep it short and to the point. 1.11. What is the ratio of the Balance of Payment (as % of service exports) in Lebanon in 2007 to that in 2011?
Give a very brief answer. 1.23. What is the ratio of the Balance of Payment (as % of service exports) in Singapore in 2007 to that in 2011?
Ensure brevity in your answer.  0.8. What is the ratio of the Balance of Payment (as % of service exports) of North America in 2008 to that in 2009?
Your answer should be very brief. 1.07. What is the ratio of the Balance of Payment (as % of service exports) in Canada in 2008 to that in 2009?
Make the answer very short. 1.04. What is the ratio of the Balance of Payment (as % of service exports) in Lebanon in 2008 to that in 2009?
Your answer should be very brief. 0.82. What is the ratio of the Balance of Payment (as % of service exports) in North America in 2008 to that in 2010?
Your answer should be very brief. 1.03. What is the ratio of the Balance of Payment (as % of service exports) in Canada in 2008 to that in 2010?
Your response must be concise. 1.01. What is the ratio of the Balance of Payment (as % of service exports) in Lebanon in 2008 to that in 2010?
Your response must be concise. 0.67. What is the ratio of the Balance of Payment (as % of service exports) of Singapore in 2008 to that in 2010?
Give a very brief answer. 0.84. What is the ratio of the Balance of Payment (as % of service exports) in North America in 2008 to that in 2011?
Keep it short and to the point. 1.04. What is the ratio of the Balance of Payment (as % of service exports) in Canada in 2008 to that in 2011?
Your answer should be very brief. 1.05. What is the ratio of the Balance of Payment (as % of service exports) of Singapore in 2008 to that in 2011?
Your answer should be compact. 0.78. What is the ratio of the Balance of Payment (as % of service exports) of North America in 2009 to that in 2010?
Keep it short and to the point. 0.96. What is the ratio of the Balance of Payment (as % of service exports) of Canada in 2009 to that in 2010?
Keep it short and to the point. 0.97. What is the ratio of the Balance of Payment (as % of service exports) in Lebanon in 2009 to that in 2010?
Provide a short and direct response. 0.82. What is the ratio of the Balance of Payment (as % of service exports) in Singapore in 2009 to that in 2010?
Offer a terse response. 0.8. What is the ratio of the Balance of Payment (as % of service exports) in North America in 2009 to that in 2011?
Ensure brevity in your answer.  0.98. What is the ratio of the Balance of Payment (as % of service exports) of Lebanon in 2009 to that in 2011?
Your answer should be compact. 1.2. What is the ratio of the Balance of Payment (as % of service exports) of Singapore in 2009 to that in 2011?
Keep it short and to the point. 0.74. What is the ratio of the Balance of Payment (as % of service exports) of North America in 2010 to that in 2011?
Offer a very short reply. 1.01. What is the ratio of the Balance of Payment (as % of service exports) of Canada in 2010 to that in 2011?
Your answer should be very brief. 1.04. What is the ratio of the Balance of Payment (as % of service exports) in Lebanon in 2010 to that in 2011?
Keep it short and to the point. 1.47. What is the ratio of the Balance of Payment (as % of service exports) in Singapore in 2010 to that in 2011?
Provide a succinct answer. 0.92. What is the difference between the highest and the second highest Balance of Payment (as % of service exports) of North America?
Make the answer very short. 0.22. What is the difference between the highest and the second highest Balance of Payment (as % of service exports) in Canada?
Offer a very short reply. 0.01. What is the difference between the highest and the second highest Balance of Payment (as % of service exports) in Lebanon?
Offer a terse response. 6.33. What is the difference between the highest and the second highest Balance of Payment (as % of service exports) of Singapore?
Give a very brief answer. 1.19. What is the difference between the highest and the lowest Balance of Payment (as % of service exports) of North America?
Provide a short and direct response. 1.82. What is the difference between the highest and the lowest Balance of Payment (as % of service exports) of Canada?
Offer a very short reply. 2.2. What is the difference between the highest and the lowest Balance of Payment (as % of service exports) of Lebanon?
Your answer should be very brief. 16.01. What is the difference between the highest and the lowest Balance of Payment (as % of service exports) in Singapore?
Your answer should be very brief. 3.98. 